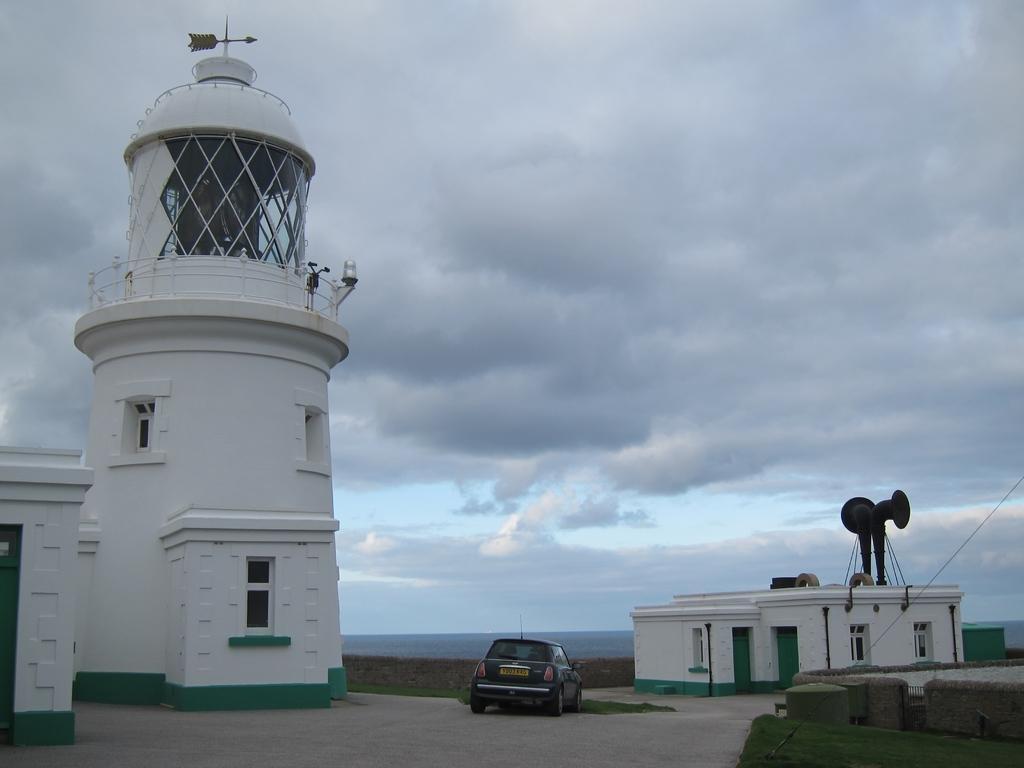How would you summarize this image in a sentence or two? In this image, we can see light house, house, walls, windows, railings, doors, car, walkways, grills and few objects. On the left side bottom, it looks like a house. Background there is a cloudy sky. Top of the image, we can see direction pole on the lighthouse. 